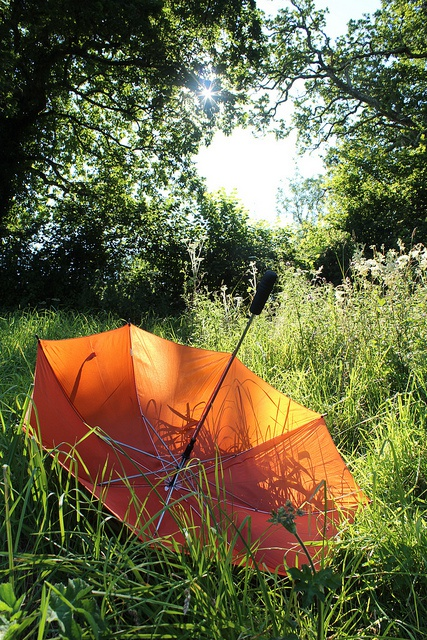Describe the objects in this image and their specific colors. I can see a umbrella in darkgreen, maroon, red, brown, and orange tones in this image. 